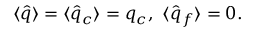Convert formula to latex. <formula><loc_0><loc_0><loc_500><loc_500>\langle \hat { q } \rangle = \langle \hat { q } _ { c } \rangle = q _ { c } \langle \hat { q } _ { f } \rangle = 0 .</formula> 